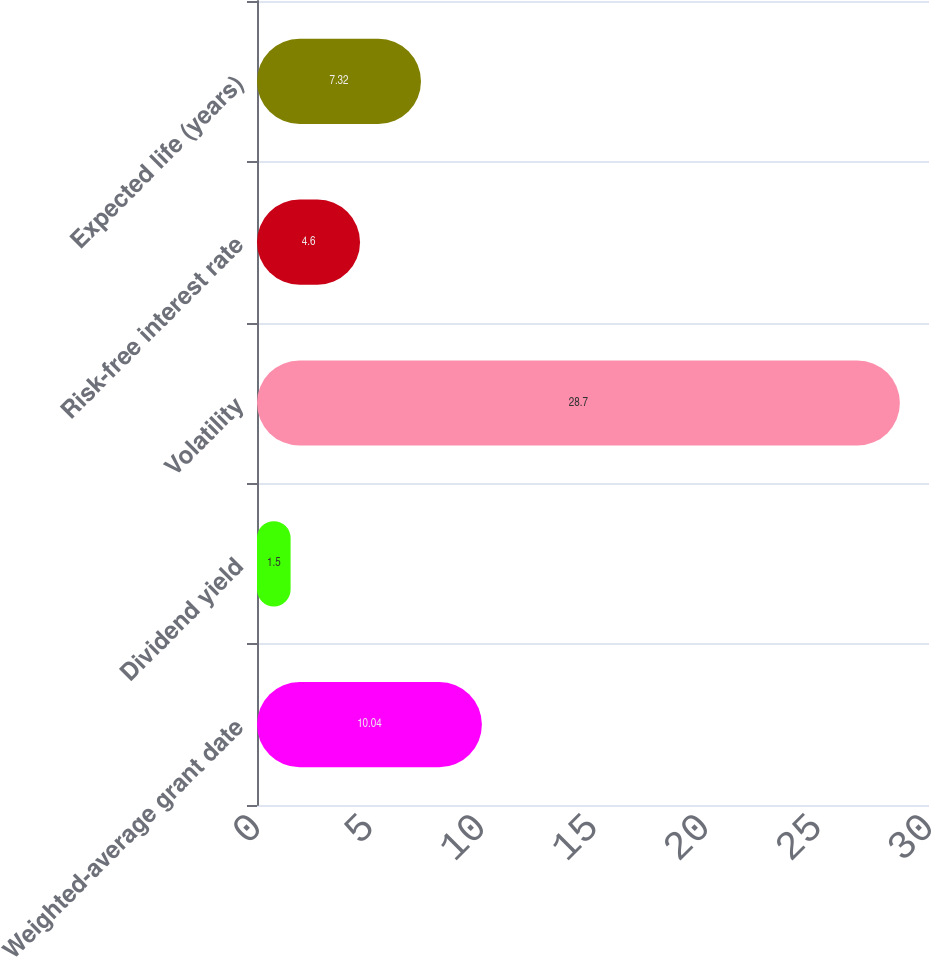Convert chart. <chart><loc_0><loc_0><loc_500><loc_500><bar_chart><fcel>Weighted-average grant date<fcel>Dividend yield<fcel>Volatility<fcel>Risk-free interest rate<fcel>Expected life (years)<nl><fcel>10.04<fcel>1.5<fcel>28.7<fcel>4.6<fcel>7.32<nl></chart> 